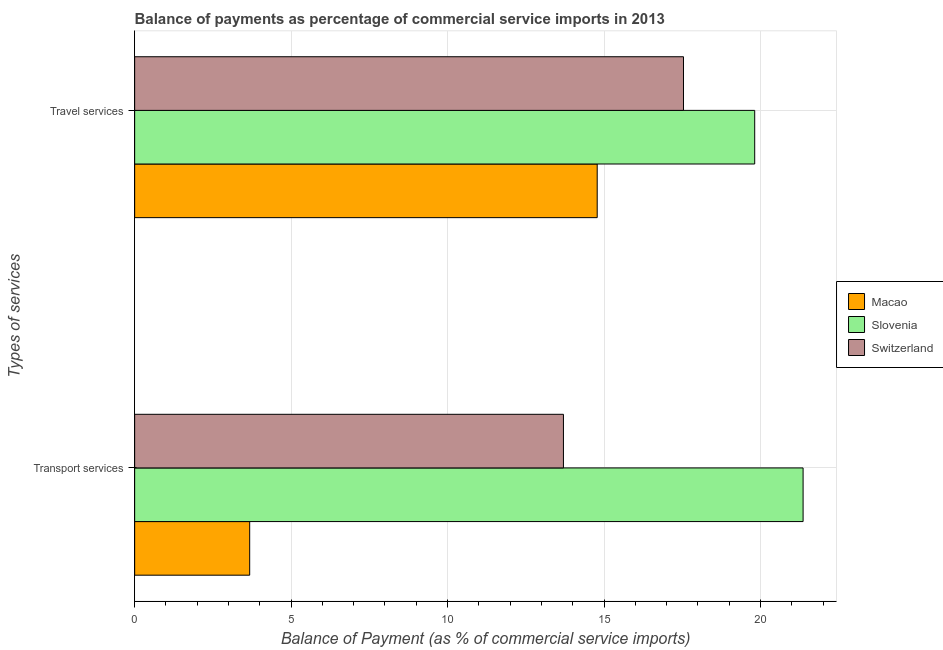How many groups of bars are there?
Offer a terse response. 2. Are the number of bars per tick equal to the number of legend labels?
Make the answer very short. Yes. How many bars are there on the 1st tick from the bottom?
Your answer should be very brief. 3. What is the label of the 1st group of bars from the top?
Provide a succinct answer. Travel services. What is the balance of payments of travel services in Macao?
Offer a terse response. 14.78. Across all countries, what is the maximum balance of payments of travel services?
Provide a succinct answer. 19.82. Across all countries, what is the minimum balance of payments of travel services?
Make the answer very short. 14.78. In which country was the balance of payments of transport services maximum?
Your answer should be very brief. Slovenia. In which country was the balance of payments of transport services minimum?
Your answer should be compact. Macao. What is the total balance of payments of travel services in the graph?
Make the answer very short. 52.14. What is the difference between the balance of payments of transport services in Macao and that in Slovenia?
Make the answer very short. -17.69. What is the difference between the balance of payments of travel services in Macao and the balance of payments of transport services in Switzerland?
Your response must be concise. 1.08. What is the average balance of payments of travel services per country?
Your answer should be very brief. 17.38. What is the difference between the balance of payments of transport services and balance of payments of travel services in Slovenia?
Make the answer very short. 1.55. In how many countries, is the balance of payments of transport services greater than 3 %?
Offer a very short reply. 3. What is the ratio of the balance of payments of travel services in Switzerland to that in Macao?
Your response must be concise. 1.19. In how many countries, is the balance of payments of transport services greater than the average balance of payments of transport services taken over all countries?
Offer a very short reply. 2. What does the 2nd bar from the top in Travel services represents?
Provide a short and direct response. Slovenia. What does the 3rd bar from the bottom in Travel services represents?
Give a very brief answer. Switzerland. Are all the bars in the graph horizontal?
Provide a short and direct response. Yes. Are the values on the major ticks of X-axis written in scientific E-notation?
Offer a very short reply. No. How are the legend labels stacked?
Ensure brevity in your answer.  Vertical. What is the title of the graph?
Ensure brevity in your answer.  Balance of payments as percentage of commercial service imports in 2013. Does "Lao PDR" appear as one of the legend labels in the graph?
Your response must be concise. No. What is the label or title of the X-axis?
Offer a terse response. Balance of Payment (as % of commercial service imports). What is the label or title of the Y-axis?
Provide a short and direct response. Types of services. What is the Balance of Payment (as % of commercial service imports) in Macao in Transport services?
Your response must be concise. 3.68. What is the Balance of Payment (as % of commercial service imports) of Slovenia in Transport services?
Give a very brief answer. 21.36. What is the Balance of Payment (as % of commercial service imports) of Switzerland in Transport services?
Provide a short and direct response. 13.7. What is the Balance of Payment (as % of commercial service imports) of Macao in Travel services?
Give a very brief answer. 14.78. What is the Balance of Payment (as % of commercial service imports) in Slovenia in Travel services?
Offer a terse response. 19.82. What is the Balance of Payment (as % of commercial service imports) in Switzerland in Travel services?
Offer a very short reply. 17.54. Across all Types of services, what is the maximum Balance of Payment (as % of commercial service imports) of Macao?
Ensure brevity in your answer.  14.78. Across all Types of services, what is the maximum Balance of Payment (as % of commercial service imports) of Slovenia?
Give a very brief answer. 21.36. Across all Types of services, what is the maximum Balance of Payment (as % of commercial service imports) in Switzerland?
Keep it short and to the point. 17.54. Across all Types of services, what is the minimum Balance of Payment (as % of commercial service imports) in Macao?
Your answer should be compact. 3.68. Across all Types of services, what is the minimum Balance of Payment (as % of commercial service imports) of Slovenia?
Offer a terse response. 19.82. Across all Types of services, what is the minimum Balance of Payment (as % of commercial service imports) in Switzerland?
Offer a very short reply. 13.7. What is the total Balance of Payment (as % of commercial service imports) of Macao in the graph?
Make the answer very short. 18.46. What is the total Balance of Payment (as % of commercial service imports) in Slovenia in the graph?
Offer a very short reply. 41.18. What is the total Balance of Payment (as % of commercial service imports) in Switzerland in the graph?
Keep it short and to the point. 31.24. What is the difference between the Balance of Payment (as % of commercial service imports) of Macao in Transport services and that in Travel services?
Provide a succinct answer. -11.11. What is the difference between the Balance of Payment (as % of commercial service imports) of Slovenia in Transport services and that in Travel services?
Provide a short and direct response. 1.55. What is the difference between the Balance of Payment (as % of commercial service imports) in Switzerland in Transport services and that in Travel services?
Keep it short and to the point. -3.84. What is the difference between the Balance of Payment (as % of commercial service imports) in Macao in Transport services and the Balance of Payment (as % of commercial service imports) in Slovenia in Travel services?
Make the answer very short. -16.14. What is the difference between the Balance of Payment (as % of commercial service imports) in Macao in Transport services and the Balance of Payment (as % of commercial service imports) in Switzerland in Travel services?
Give a very brief answer. -13.86. What is the difference between the Balance of Payment (as % of commercial service imports) of Slovenia in Transport services and the Balance of Payment (as % of commercial service imports) of Switzerland in Travel services?
Provide a succinct answer. 3.82. What is the average Balance of Payment (as % of commercial service imports) in Macao per Types of services?
Your answer should be compact. 9.23. What is the average Balance of Payment (as % of commercial service imports) in Slovenia per Types of services?
Give a very brief answer. 20.59. What is the average Balance of Payment (as % of commercial service imports) in Switzerland per Types of services?
Offer a terse response. 15.62. What is the difference between the Balance of Payment (as % of commercial service imports) in Macao and Balance of Payment (as % of commercial service imports) in Slovenia in Transport services?
Give a very brief answer. -17.69. What is the difference between the Balance of Payment (as % of commercial service imports) in Macao and Balance of Payment (as % of commercial service imports) in Switzerland in Transport services?
Provide a short and direct response. -10.03. What is the difference between the Balance of Payment (as % of commercial service imports) in Slovenia and Balance of Payment (as % of commercial service imports) in Switzerland in Transport services?
Your response must be concise. 7.66. What is the difference between the Balance of Payment (as % of commercial service imports) of Macao and Balance of Payment (as % of commercial service imports) of Slovenia in Travel services?
Give a very brief answer. -5.03. What is the difference between the Balance of Payment (as % of commercial service imports) of Macao and Balance of Payment (as % of commercial service imports) of Switzerland in Travel services?
Provide a short and direct response. -2.76. What is the difference between the Balance of Payment (as % of commercial service imports) in Slovenia and Balance of Payment (as % of commercial service imports) in Switzerland in Travel services?
Provide a short and direct response. 2.28. What is the ratio of the Balance of Payment (as % of commercial service imports) in Macao in Transport services to that in Travel services?
Your answer should be very brief. 0.25. What is the ratio of the Balance of Payment (as % of commercial service imports) in Slovenia in Transport services to that in Travel services?
Your answer should be very brief. 1.08. What is the ratio of the Balance of Payment (as % of commercial service imports) of Switzerland in Transport services to that in Travel services?
Your response must be concise. 0.78. What is the difference between the highest and the second highest Balance of Payment (as % of commercial service imports) of Macao?
Your response must be concise. 11.11. What is the difference between the highest and the second highest Balance of Payment (as % of commercial service imports) in Slovenia?
Your answer should be compact. 1.55. What is the difference between the highest and the second highest Balance of Payment (as % of commercial service imports) in Switzerland?
Provide a succinct answer. 3.84. What is the difference between the highest and the lowest Balance of Payment (as % of commercial service imports) in Macao?
Your answer should be compact. 11.11. What is the difference between the highest and the lowest Balance of Payment (as % of commercial service imports) of Slovenia?
Ensure brevity in your answer.  1.55. What is the difference between the highest and the lowest Balance of Payment (as % of commercial service imports) of Switzerland?
Give a very brief answer. 3.84. 